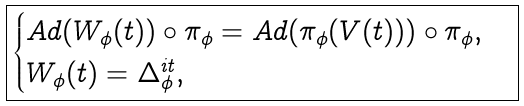<formula> <loc_0><loc_0><loc_500><loc_500>\boxed { \begin{cases} A d ( W _ { \phi } ( t ) ) \circ \pi _ { \phi } = A d ( \pi _ { \phi } ( V ( t ) ) ) \circ \pi _ { \phi } , \\ W _ { \phi } ( t ) = \Delta _ { \phi } ^ { i t } , \end{cases} }</formula> 